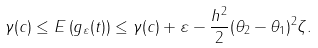<formula> <loc_0><loc_0><loc_500><loc_500>\gamma ( c ) \leq E \left ( g _ { \varepsilon } ( t ) \right ) \leq \gamma ( c ) + \varepsilon - \frac { h ^ { 2 } } { 2 } ( \theta _ { 2 } - \theta _ { 1 } ) ^ { 2 } \zeta .</formula> 